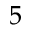<formula> <loc_0><loc_0><loc_500><loc_500>5</formula> 